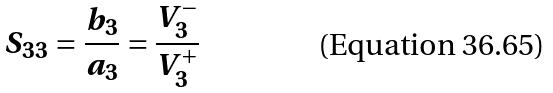<formula> <loc_0><loc_0><loc_500><loc_500>S _ { 3 3 } = \frac { b _ { 3 } } { a _ { 3 } } = \frac { V _ { 3 } ^ { - } } { V _ { 3 } ^ { + } }</formula> 